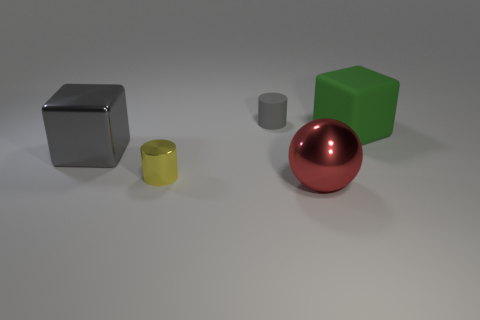Does the metallic cylinder have the same color as the large rubber cube?
Offer a very short reply. No. What number of big things are either cyan shiny blocks or gray cylinders?
Your response must be concise. 0. Are there any other things that have the same color as the large metallic sphere?
Keep it short and to the point. No. The tiny yellow object that is the same material as the large gray thing is what shape?
Your answer should be very brief. Cylinder. There is a metallic object behind the tiny yellow metallic cylinder; what size is it?
Ensure brevity in your answer.  Large. The big green rubber object is what shape?
Your answer should be compact. Cube. Does the gray metal object behind the tiny yellow thing have the same size as the cube that is on the right side of the big gray thing?
Make the answer very short. Yes. What is the size of the gray object that is behind the big metallic object to the left of the big thing in front of the big gray metal block?
Provide a short and direct response. Small. There is a gray object that is behind the block behind the big cube that is in front of the big green rubber thing; what shape is it?
Your answer should be compact. Cylinder. There is a large object that is left of the large red shiny object; what shape is it?
Provide a succinct answer. Cube. 